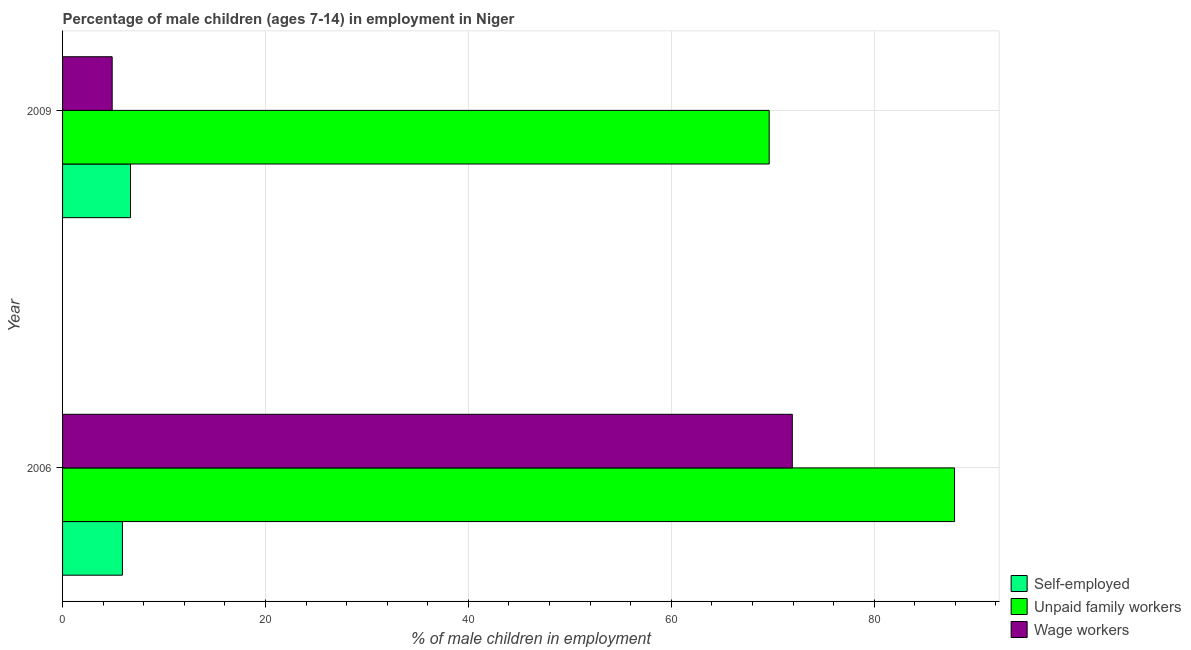How many different coloured bars are there?
Make the answer very short. 3. Are the number of bars on each tick of the Y-axis equal?
Your answer should be very brief. Yes. How many bars are there on the 1st tick from the top?
Offer a very short reply. 3. What is the percentage of children employed as wage workers in 2006?
Offer a terse response. 71.93. Across all years, what is the maximum percentage of children employed as wage workers?
Ensure brevity in your answer.  71.93. Across all years, what is the minimum percentage of children employed as unpaid family workers?
Your response must be concise. 69.65. In which year was the percentage of children employed as unpaid family workers maximum?
Provide a short and direct response. 2006. In which year was the percentage of children employed as wage workers minimum?
Give a very brief answer. 2009. What is the total percentage of self employed children in the graph?
Ensure brevity in your answer.  12.6. What is the difference between the percentage of children employed as wage workers in 2006 and the percentage of self employed children in 2009?
Your answer should be compact. 65.23. What is the average percentage of children employed as wage workers per year?
Provide a succinct answer. 38.41. In the year 2009, what is the difference between the percentage of children employed as unpaid family workers and percentage of children employed as wage workers?
Provide a succinct answer. 64.76. In how many years, is the percentage of children employed as wage workers greater than 16 %?
Offer a very short reply. 1. What is the ratio of the percentage of children employed as unpaid family workers in 2006 to that in 2009?
Provide a short and direct response. 1.26. Is the difference between the percentage of children employed as wage workers in 2006 and 2009 greater than the difference between the percentage of children employed as unpaid family workers in 2006 and 2009?
Offer a terse response. Yes. In how many years, is the percentage of self employed children greater than the average percentage of self employed children taken over all years?
Offer a terse response. 1. What does the 3rd bar from the top in 2009 represents?
Your answer should be compact. Self-employed. What does the 2nd bar from the bottom in 2006 represents?
Provide a short and direct response. Unpaid family workers. Is it the case that in every year, the sum of the percentage of self employed children and percentage of children employed as unpaid family workers is greater than the percentage of children employed as wage workers?
Provide a short and direct response. Yes. How many bars are there?
Give a very brief answer. 6. How many years are there in the graph?
Your response must be concise. 2. Does the graph contain any zero values?
Ensure brevity in your answer.  No. Does the graph contain grids?
Your answer should be very brief. Yes. Where does the legend appear in the graph?
Your answer should be compact. Bottom right. How many legend labels are there?
Your answer should be compact. 3. How are the legend labels stacked?
Your answer should be compact. Vertical. What is the title of the graph?
Make the answer very short. Percentage of male children (ages 7-14) in employment in Niger. Does "Labor Market" appear as one of the legend labels in the graph?
Provide a short and direct response. No. What is the label or title of the X-axis?
Offer a very short reply. % of male children in employment. What is the label or title of the Y-axis?
Provide a succinct answer. Year. What is the % of male children in employment in Self-employed in 2006?
Offer a very short reply. 5.9. What is the % of male children in employment of Unpaid family workers in 2006?
Provide a short and direct response. 87.92. What is the % of male children in employment of Wage workers in 2006?
Give a very brief answer. 71.93. What is the % of male children in employment in Unpaid family workers in 2009?
Your answer should be very brief. 69.65. What is the % of male children in employment of Wage workers in 2009?
Offer a terse response. 4.89. Across all years, what is the maximum % of male children in employment in Self-employed?
Your answer should be compact. 6.7. Across all years, what is the maximum % of male children in employment of Unpaid family workers?
Ensure brevity in your answer.  87.92. Across all years, what is the maximum % of male children in employment of Wage workers?
Provide a succinct answer. 71.93. Across all years, what is the minimum % of male children in employment in Unpaid family workers?
Offer a terse response. 69.65. Across all years, what is the minimum % of male children in employment in Wage workers?
Provide a succinct answer. 4.89. What is the total % of male children in employment of Unpaid family workers in the graph?
Offer a terse response. 157.57. What is the total % of male children in employment of Wage workers in the graph?
Ensure brevity in your answer.  76.82. What is the difference between the % of male children in employment of Unpaid family workers in 2006 and that in 2009?
Offer a very short reply. 18.27. What is the difference between the % of male children in employment of Wage workers in 2006 and that in 2009?
Provide a short and direct response. 67.04. What is the difference between the % of male children in employment in Self-employed in 2006 and the % of male children in employment in Unpaid family workers in 2009?
Provide a short and direct response. -63.75. What is the difference between the % of male children in employment of Self-employed in 2006 and the % of male children in employment of Wage workers in 2009?
Offer a very short reply. 1.01. What is the difference between the % of male children in employment in Unpaid family workers in 2006 and the % of male children in employment in Wage workers in 2009?
Ensure brevity in your answer.  83.03. What is the average % of male children in employment in Unpaid family workers per year?
Give a very brief answer. 78.78. What is the average % of male children in employment of Wage workers per year?
Keep it short and to the point. 38.41. In the year 2006, what is the difference between the % of male children in employment in Self-employed and % of male children in employment in Unpaid family workers?
Your answer should be compact. -82.02. In the year 2006, what is the difference between the % of male children in employment of Self-employed and % of male children in employment of Wage workers?
Ensure brevity in your answer.  -66.03. In the year 2006, what is the difference between the % of male children in employment in Unpaid family workers and % of male children in employment in Wage workers?
Offer a terse response. 15.99. In the year 2009, what is the difference between the % of male children in employment of Self-employed and % of male children in employment of Unpaid family workers?
Offer a very short reply. -62.95. In the year 2009, what is the difference between the % of male children in employment of Self-employed and % of male children in employment of Wage workers?
Keep it short and to the point. 1.81. In the year 2009, what is the difference between the % of male children in employment in Unpaid family workers and % of male children in employment in Wage workers?
Your answer should be compact. 64.76. What is the ratio of the % of male children in employment of Self-employed in 2006 to that in 2009?
Your response must be concise. 0.88. What is the ratio of the % of male children in employment of Unpaid family workers in 2006 to that in 2009?
Give a very brief answer. 1.26. What is the ratio of the % of male children in employment in Wage workers in 2006 to that in 2009?
Your answer should be compact. 14.71. What is the difference between the highest and the second highest % of male children in employment in Unpaid family workers?
Provide a short and direct response. 18.27. What is the difference between the highest and the second highest % of male children in employment of Wage workers?
Keep it short and to the point. 67.04. What is the difference between the highest and the lowest % of male children in employment of Unpaid family workers?
Give a very brief answer. 18.27. What is the difference between the highest and the lowest % of male children in employment in Wage workers?
Keep it short and to the point. 67.04. 